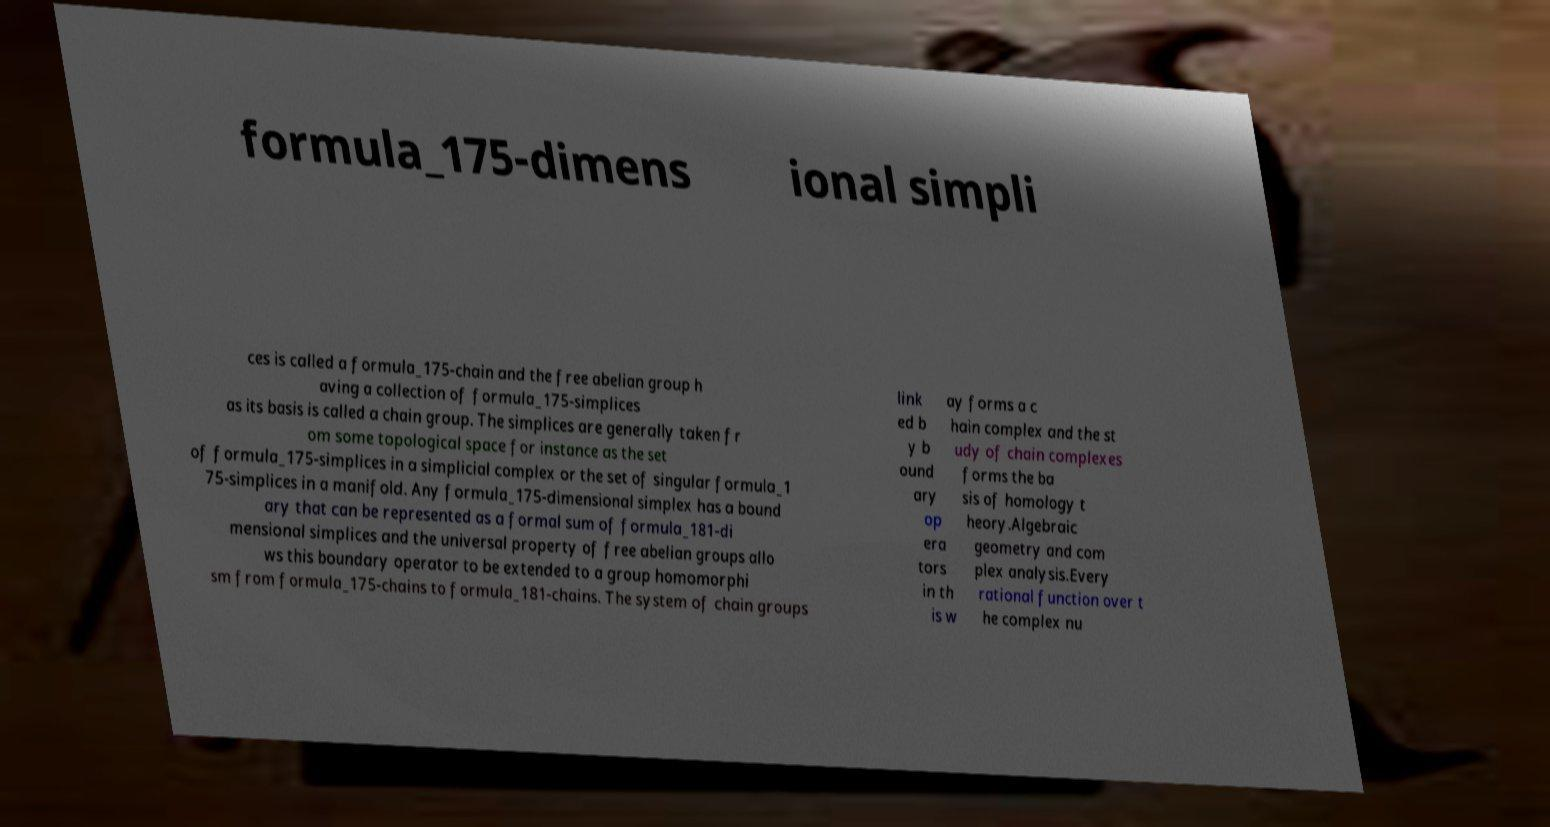For documentation purposes, I need the text within this image transcribed. Could you provide that? formula_175-dimens ional simpli ces is called a formula_175-chain and the free abelian group h aving a collection of formula_175-simplices as its basis is called a chain group. The simplices are generally taken fr om some topological space for instance as the set of formula_175-simplices in a simplicial complex or the set of singular formula_1 75-simplices in a manifold. Any formula_175-dimensional simplex has a bound ary that can be represented as a formal sum of formula_181-di mensional simplices and the universal property of free abelian groups allo ws this boundary operator to be extended to a group homomorphi sm from formula_175-chains to formula_181-chains. The system of chain groups link ed b y b ound ary op era tors in th is w ay forms a c hain complex and the st udy of chain complexes forms the ba sis of homology t heory.Algebraic geometry and com plex analysis.Every rational function over t he complex nu 